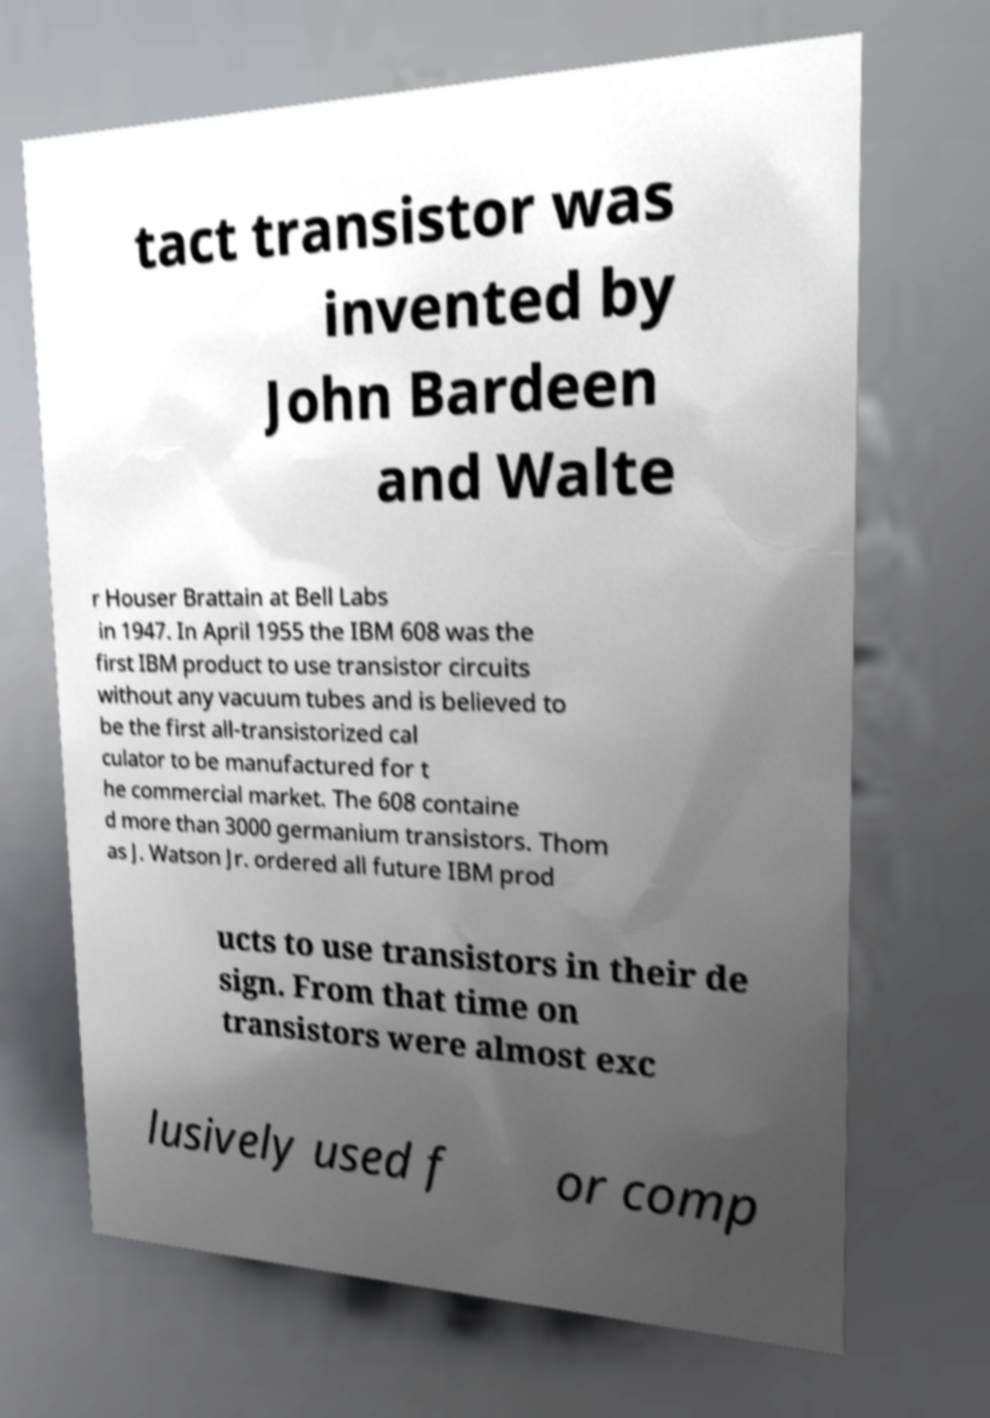There's text embedded in this image that I need extracted. Can you transcribe it verbatim? tact transistor was invented by John Bardeen and Walte r Houser Brattain at Bell Labs in 1947. In April 1955 the IBM 608 was the first IBM product to use transistor circuits without any vacuum tubes and is believed to be the first all-transistorized cal culator to be manufactured for t he commercial market. The 608 containe d more than 3000 germanium transistors. Thom as J. Watson Jr. ordered all future IBM prod ucts to use transistors in their de sign. From that time on transistors were almost exc lusively used f or comp 